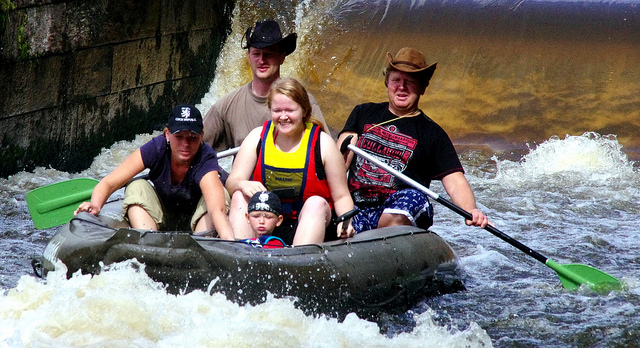Describe the environment around the raft. The raft is situated on a fast-moving river with white water rapids, indicating a possibly rocky and uneven riverbed below. The river flows between densely forested banks, suggesting a remote or natural area less impacted by urban development. The water appears somewhat murky, typical of rivers through forested or earthen areas. 